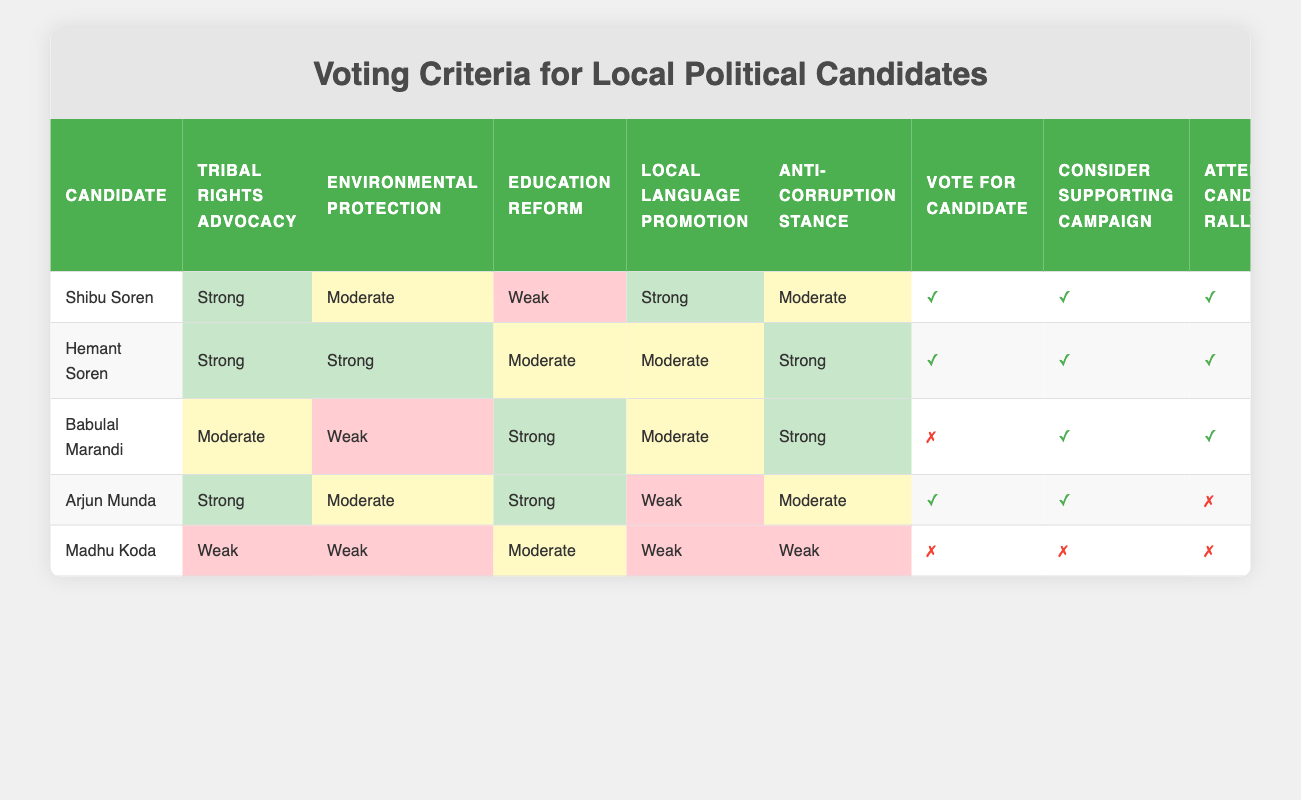What are the voting criteria for Shibu Soren? The criteria for voting for Shibu Soren are that he strongly advocates for tribal rights and local language promotion, has a moderate stance on environmental protection and anti-corruption, and a weak stance on education reform. Since he meets the high criteria for tribal rights and local language, the decision indicates yes for voting.
Answer: Yes Which candidate has the weakest anti-corruption stance? Madhu Koda has a weak anti-corruption stance, which is lower than all other candidates in the table. In the anti-corruption stance column, his level is categorized as weak.
Answer: Madhu Koda How many candidates can you share messages for on social media? To find out, we can count the candidates with a true value in the "Share candidate's message on social media" column. Shibu Soren, Hemant Soren, and Arjun Munda all allow for sharing, while Babulal Marandi and Madhu Koda do not. So, the total is three candidates.
Answer: 3 Is Hemant Soren weaker in environmental protection than Babulal Marandi? Hemant Soren has a strong advocacy for environmental protection while Babulal Marandi is weak in this area. Comparing the two, Hemant Soren is definitely stronger, so this statement is false.
Answer: No Which candidate has the highest number of activities suggested for them? The activities for each candidate can be counted by their true values across all action categories. Shibu Soren and Hemant Soren have five suggested activities, while others have fewer. Therefore, the answer is Shibu Soren and Hemant Soren, who share the highest total.
Answer: Shibu Soren and Hemant Soren What is the total number of candidates with a strong stance on education reform? We can examine the education reform column and count how many candidates are listed as having a strong stance. Arjun Munda and Babulal Marandi are the only candidates listed with a strong education reform stance. Thus, there are two candidates in total.
Answer: 2 If someone supports a candidate based on local language promotion alone, which candidates would they consider? We look at the local language promotion column to find candidates with a strong stance. Shibu Soren and Hemant Soren both have a strong local language promotion stance. Therefore, those two candidates can be considered based on this criterion.
Answer: Shibu Soren and Hemant Soren How many candidates have only one activity under consideration? By checking the "Volunteering for candidate" column, we find that Babulal Marandi and Madhu Koda have no activities suggested, only Hemant Soren has one fewer (volunteer = false). Therefore, they are counted as those having only one activity.
Answer: 2 